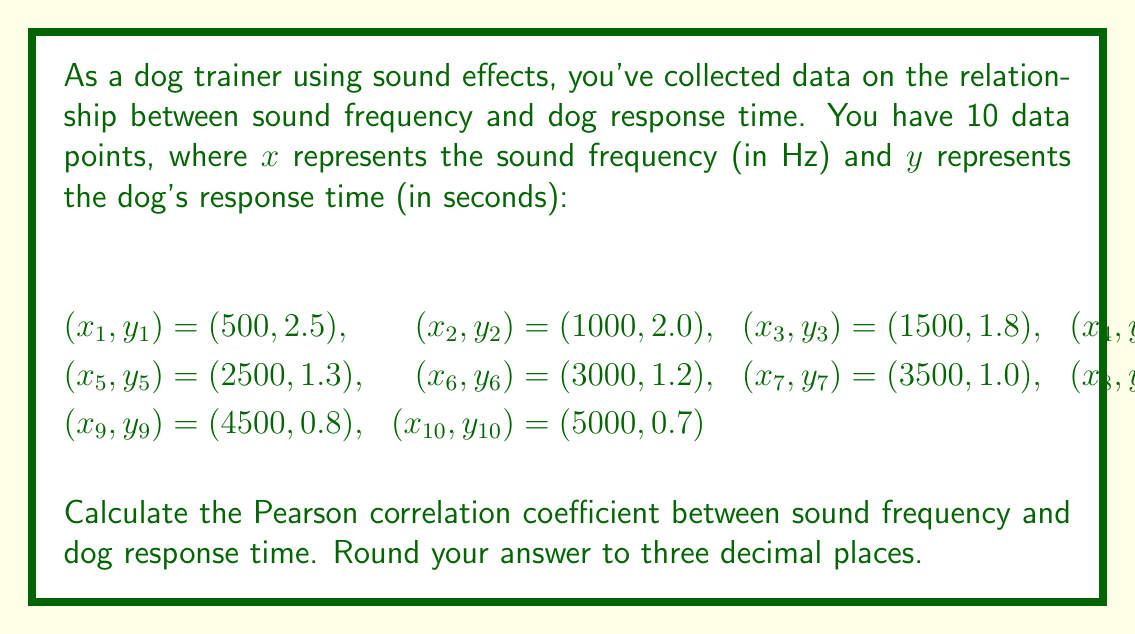What is the answer to this math problem? To calculate the Pearson correlation coefficient, we'll use the formula:

$$r = \frac{\sum_{i=1}^{n} (x_i - \bar{x})(y_i - \bar{y})}{\sqrt{\sum_{i=1}^{n} (x_i - \bar{x})^2} \sqrt{\sum_{i=1}^{n} (y_i - \bar{y})^2}}$$

Where $\bar{x}$ and $\bar{y}$ are the means of $x$ and $y$ respectively.

Step 1: Calculate $\bar{x}$ and $\bar{y}$
$\bar{x} = \frac{1}{10} \sum_{i=1}^{10} x_i = 2800$ Hz
$\bar{y} = \frac{1}{10} \sum_{i=1}^{10} y_i = 1.37$ seconds

Step 2: Calculate $(x_i - \bar{x})$, $(y_i - \bar{y})$, $(x_i - \bar{x})^2$, $(y_i - \bar{y})^2$, and $(x_i - \bar{x})(y_i - \bar{y})$ for each data point.

Step 3: Sum up the values from Step 2
$\sum_{i=1}^{10} (x_i - \bar{x})(y_i - \bar{y}) = -3,435,000$
$\sum_{i=1}^{10} (x_i - \bar{x})^2 = 20,250,000$
$\sum_{i=1}^{10} (y_i - \bar{y})^2 = 2.8665$

Step 4: Apply the formula
$$r = \frac{-3,435,000}{\sqrt{20,250,000} \sqrt{2.8665}} = -0.99758$$

Step 5: Round to three decimal places
$r \approx -0.998$
Answer: The Pearson correlation coefficient between sound frequency and dog response time is approximately -0.998. 